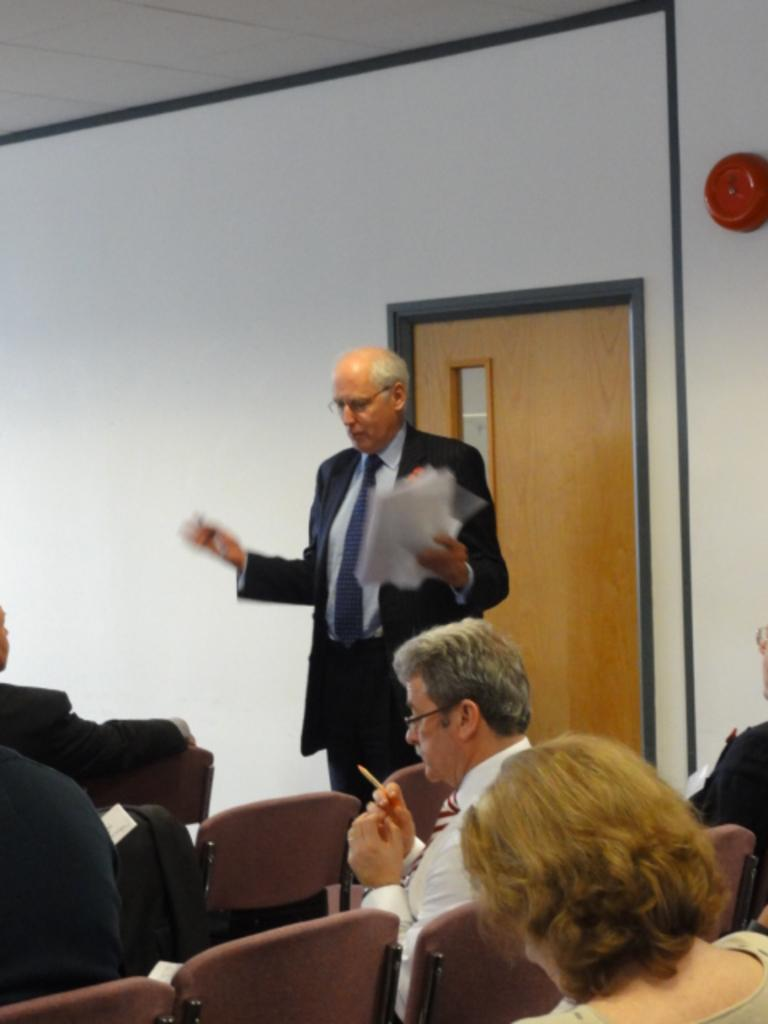What are the persons in the image doing? The persons in the image are sitting on chairs. Is there anyone standing in the image? Yes, there is a person standing in the image. What is the standing person holding? The standing person is holding papers. What can be seen in the background of the image? There is a wall and a door in the background of the image. What type of glove is the person wearing in the image? There is no glove present in the image; the standing person is holding papers. What color is the hair of the person sitting on the chair? The provided facts do not mention the color of anyone's hair in the image. 